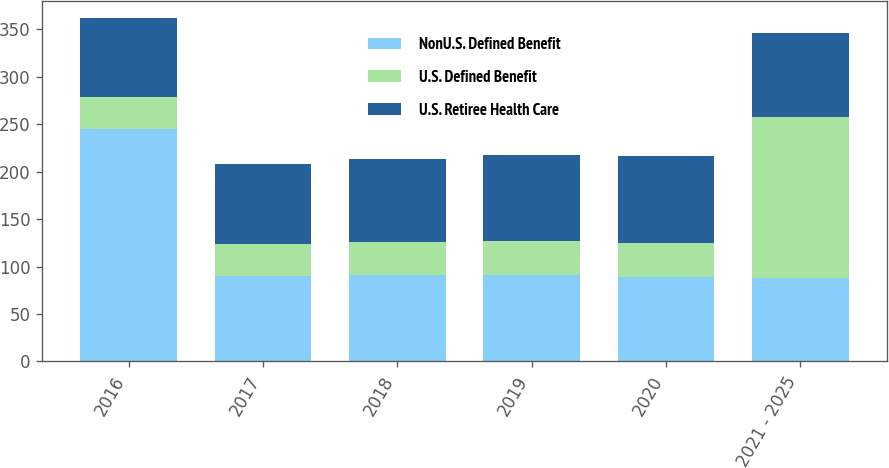Convert chart to OTSL. <chart><loc_0><loc_0><loc_500><loc_500><stacked_bar_chart><ecel><fcel>2016<fcel>2017<fcel>2018<fcel>2019<fcel>2020<fcel>2021 - 2025<nl><fcel>NonU.S. Defined Benefit<fcel>245<fcel>90<fcel>91<fcel>91<fcel>89<fcel>88<nl><fcel>U.S. Defined Benefit<fcel>34<fcel>34<fcel>35<fcel>36<fcel>36<fcel>170<nl><fcel>U.S. Retiree Health Care<fcel>83<fcel>84<fcel>87<fcel>91<fcel>92<fcel>88<nl></chart> 